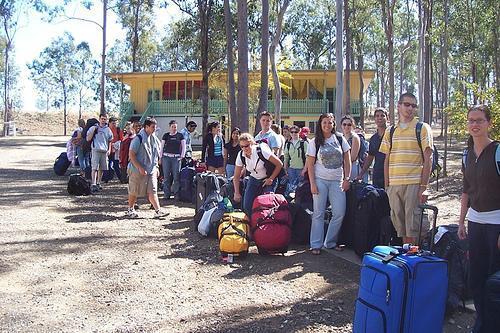How many visible people are wearing yellow?
Give a very brief answer. 1. How many people can you see?
Give a very brief answer. 6. How many suitcases are there?
Give a very brief answer. 2. 